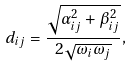Convert formula to latex. <formula><loc_0><loc_0><loc_500><loc_500>d _ { i j } = \frac { \sqrt { \alpha _ { i j } ^ { 2 } + \beta _ { i j } ^ { 2 } } } { 2 \sqrt { \omega _ { i } \omega _ { j } } } ,</formula> 